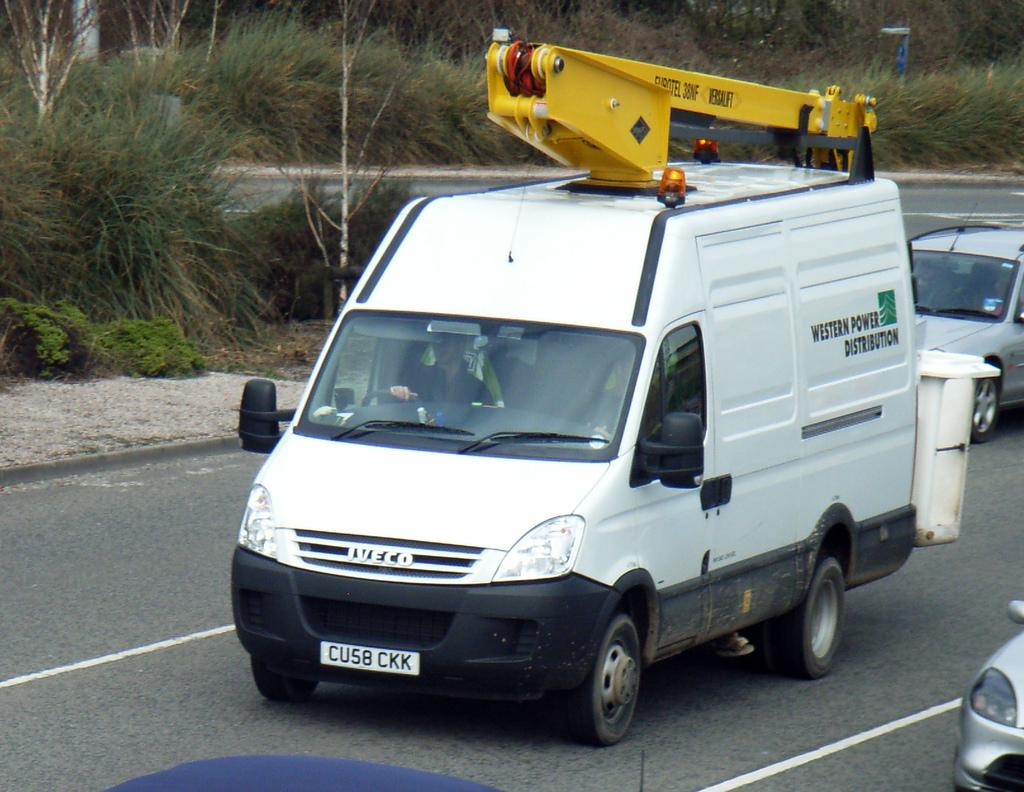<image>
Share a concise interpretation of the image provided. White van with a license plate which says CU58CKK. 